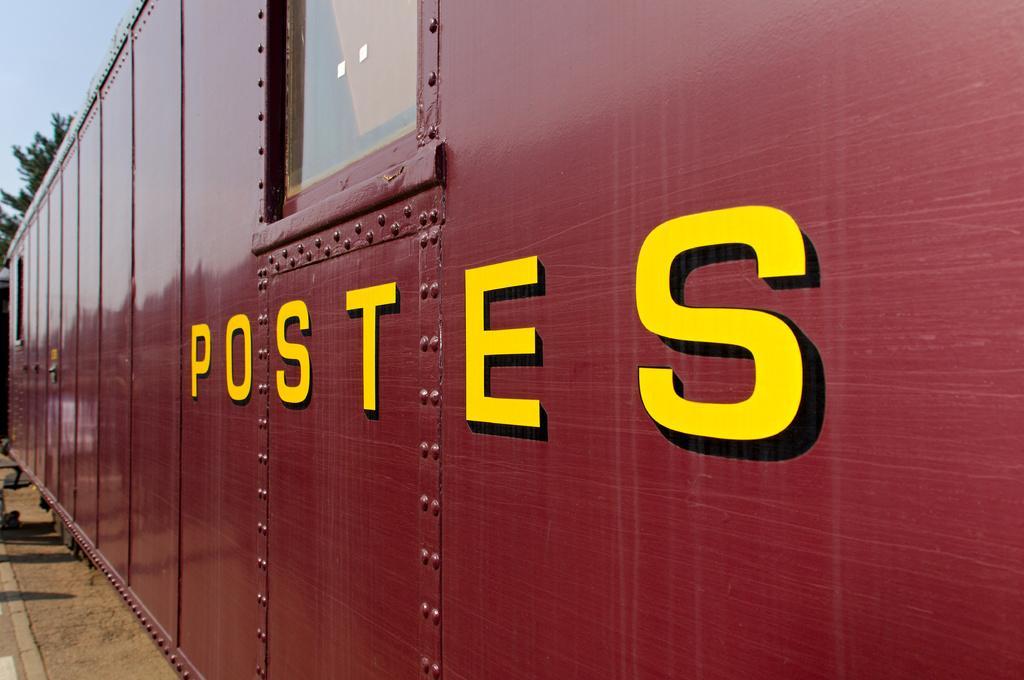Can you describe this image briefly? In this image there is a bogie of a train. There are glass windows to the train. There is text on the walls of the train. Behind the train there are trees. At the top there is the sky. In the bottom left there is the ground. 